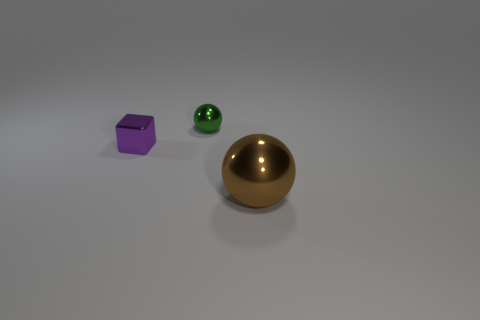What number of rubber objects are either blue cylinders or purple things?
Offer a very short reply. 0. What material is the purple thing that is the same size as the green sphere?
Offer a very short reply. Metal. Is there a tiny gray object made of the same material as the small green sphere?
Your response must be concise. No. There is a object in front of the tiny shiny thing that is in front of the ball that is behind the big sphere; what shape is it?
Give a very brief answer. Sphere. There is a green shiny thing; does it have the same size as the block that is on the left side of the tiny green thing?
Offer a very short reply. Yes. The metallic object that is both on the right side of the purple block and behind the large thing has what shape?
Your response must be concise. Sphere. What number of small things are either shiny objects or cubes?
Offer a terse response. 2. Are there the same number of cubes in front of the small purple metal cube and shiny blocks on the right side of the large brown object?
Your answer should be compact. Yes. What number of other objects are there of the same color as the block?
Your answer should be compact. 0. Is the number of tiny green things in front of the green object the same as the number of purple things?
Your answer should be compact. No. 